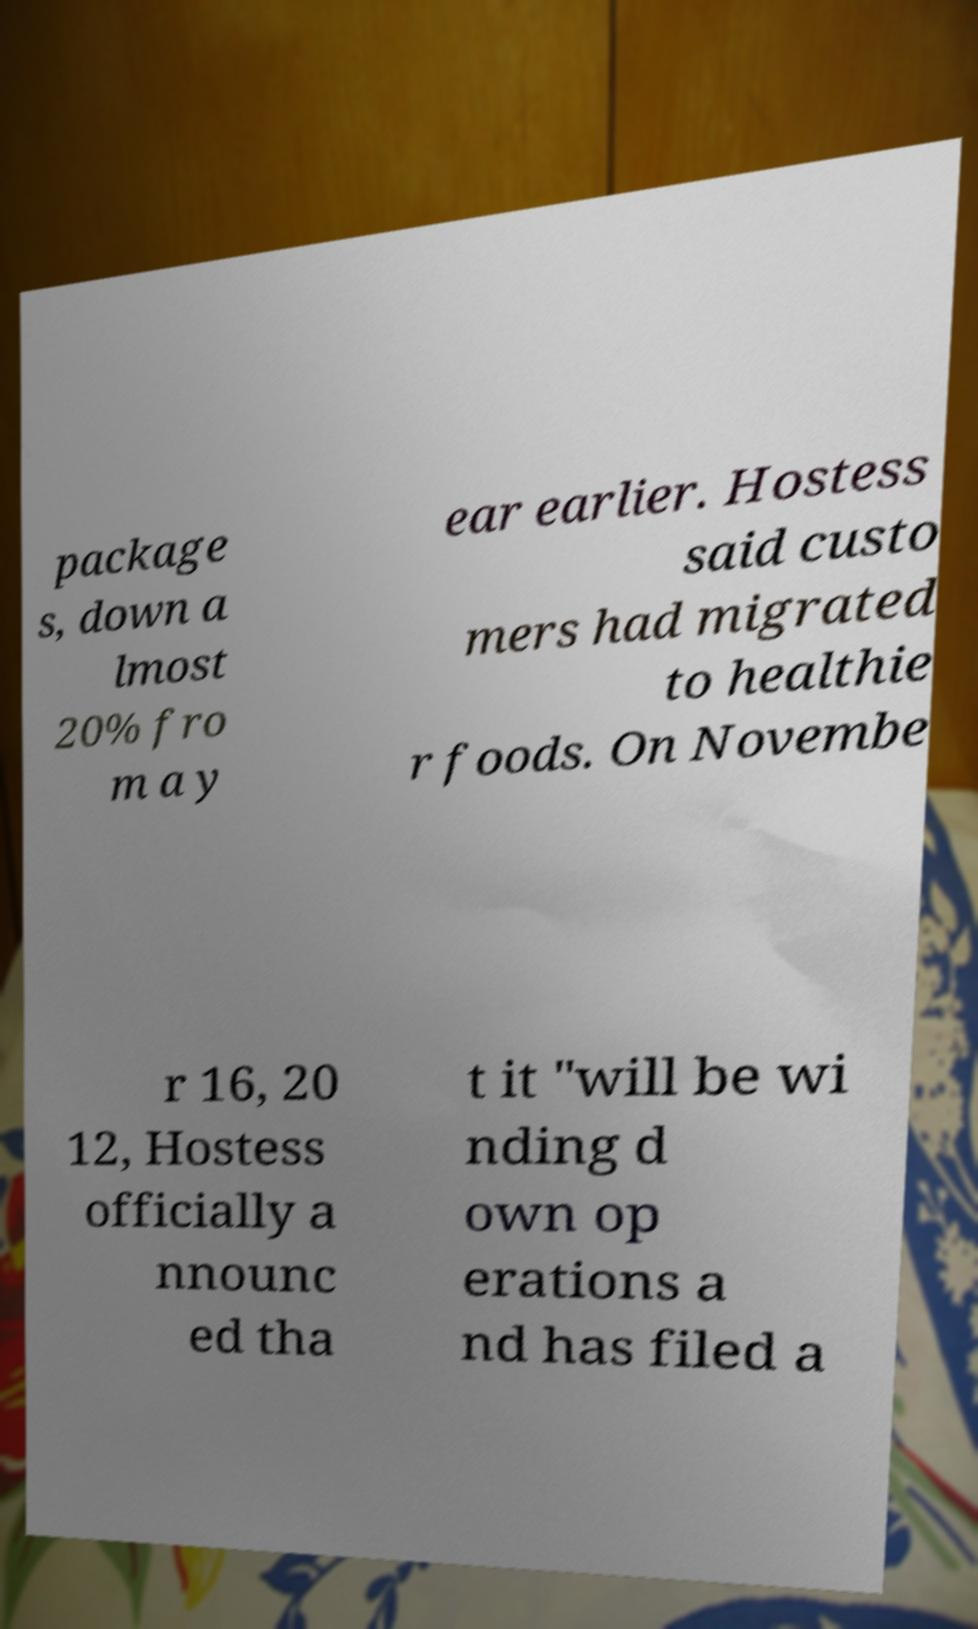Please identify and transcribe the text found in this image. package s, down a lmost 20% fro m a y ear earlier. Hostess said custo mers had migrated to healthie r foods. On Novembe r 16, 20 12, Hostess officially a nnounc ed tha t it "will be wi nding d own op erations a nd has filed a 